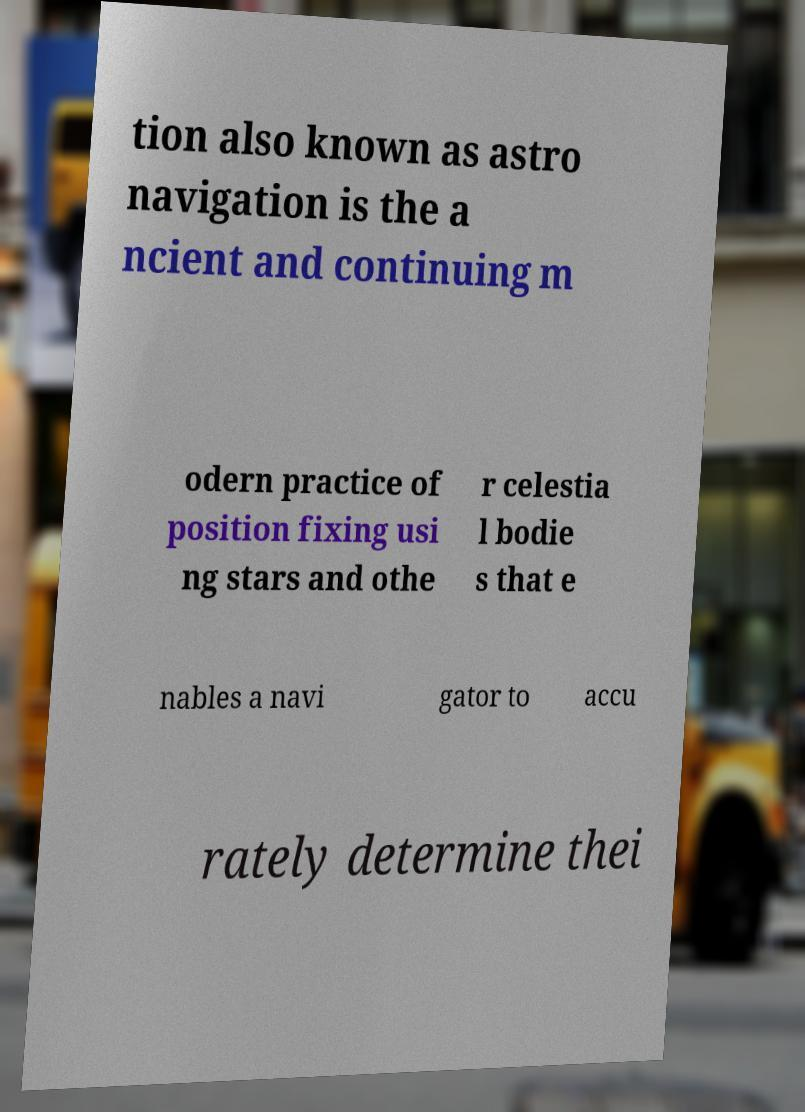Can you accurately transcribe the text from the provided image for me? tion also known as astro navigation is the a ncient and continuing m odern practice of position fixing usi ng stars and othe r celestia l bodie s that e nables a navi gator to accu rately determine thei 